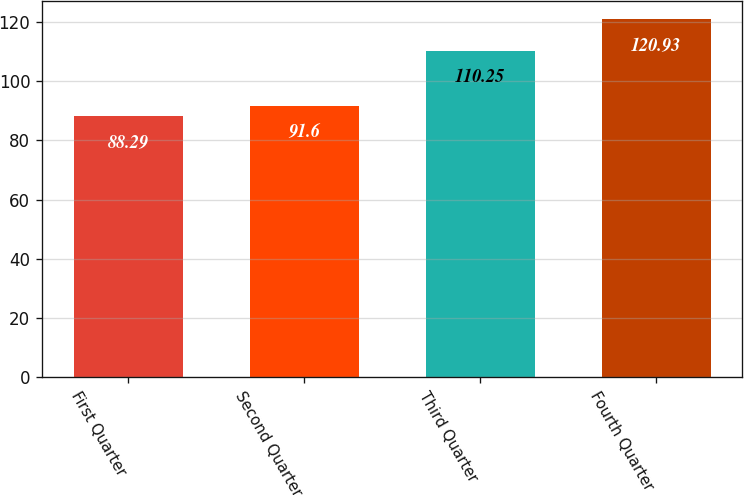Convert chart. <chart><loc_0><loc_0><loc_500><loc_500><bar_chart><fcel>First Quarter<fcel>Second Quarter<fcel>Third Quarter<fcel>Fourth Quarter<nl><fcel>88.29<fcel>91.6<fcel>110.25<fcel>120.93<nl></chart> 